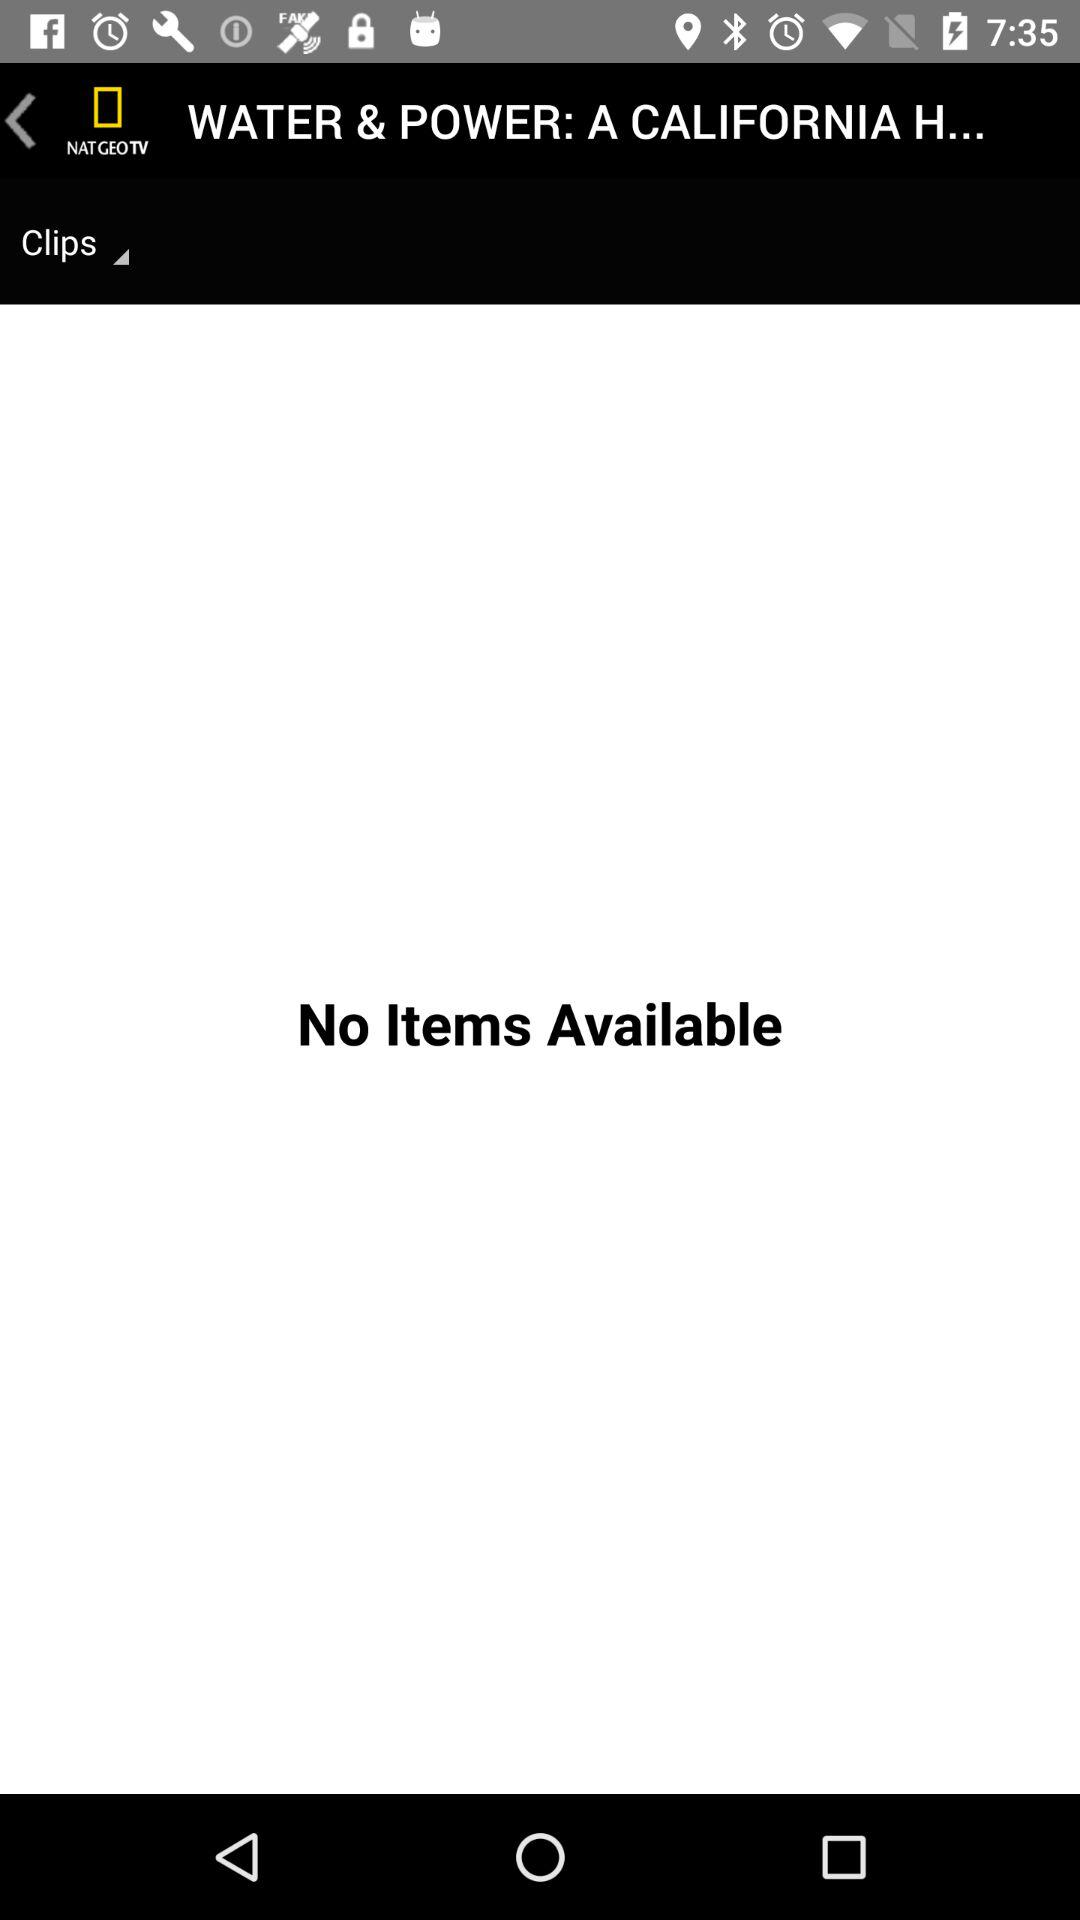What is the name of the application? The name of the application is "Nat Geo TV". 